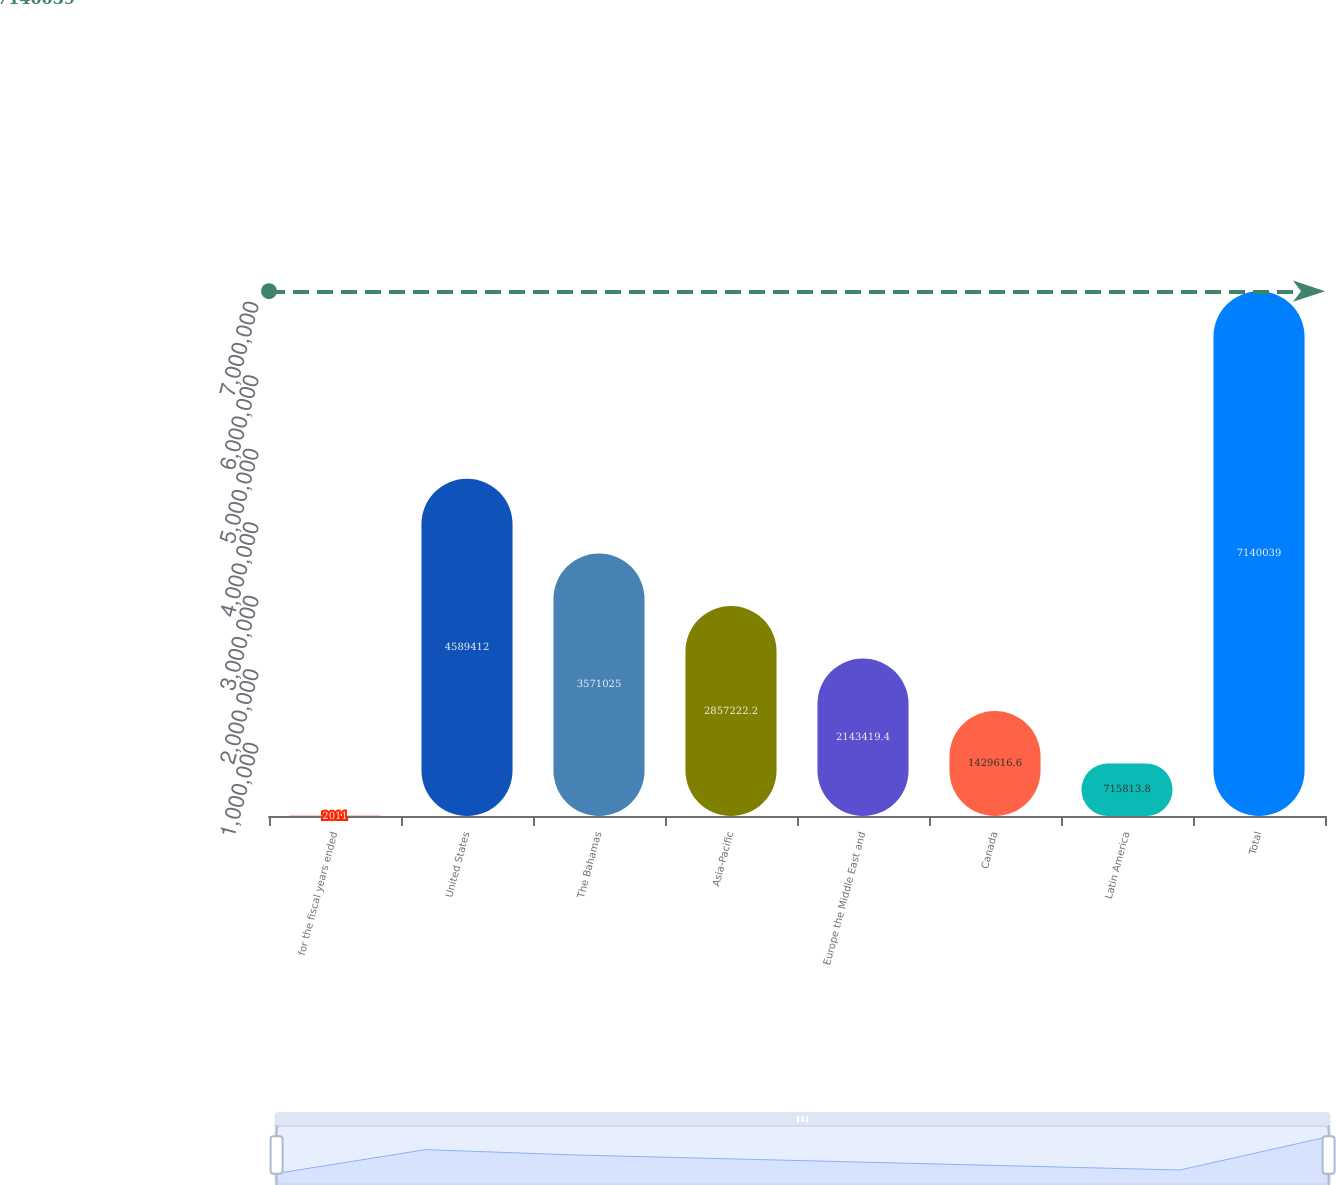<chart> <loc_0><loc_0><loc_500><loc_500><bar_chart><fcel>for the fiscal years ended<fcel>United States<fcel>The Bahamas<fcel>Asia-Pacific<fcel>Europe the Middle East and<fcel>Canada<fcel>Latin America<fcel>Total<nl><fcel>2011<fcel>4.58941e+06<fcel>3.57102e+06<fcel>2.85722e+06<fcel>2.14342e+06<fcel>1.42962e+06<fcel>715814<fcel>7.14004e+06<nl></chart> 